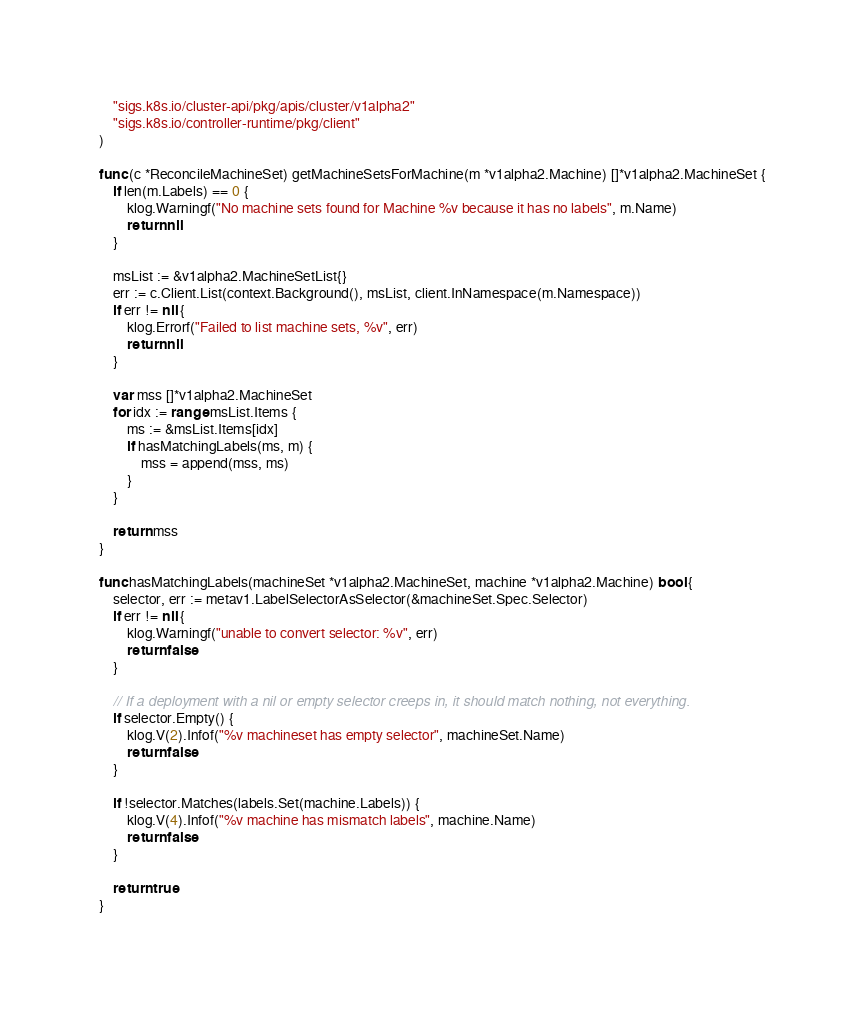Convert code to text. <code><loc_0><loc_0><loc_500><loc_500><_Go_>	"sigs.k8s.io/cluster-api/pkg/apis/cluster/v1alpha2"
	"sigs.k8s.io/controller-runtime/pkg/client"
)

func (c *ReconcileMachineSet) getMachineSetsForMachine(m *v1alpha2.Machine) []*v1alpha2.MachineSet {
	if len(m.Labels) == 0 {
		klog.Warningf("No machine sets found for Machine %v because it has no labels", m.Name)
		return nil
	}

	msList := &v1alpha2.MachineSetList{}
	err := c.Client.List(context.Background(), msList, client.InNamespace(m.Namespace))
	if err != nil {
		klog.Errorf("Failed to list machine sets, %v", err)
		return nil
	}

	var mss []*v1alpha2.MachineSet
	for idx := range msList.Items {
		ms := &msList.Items[idx]
		if hasMatchingLabels(ms, m) {
			mss = append(mss, ms)
		}
	}

	return mss
}

func hasMatchingLabels(machineSet *v1alpha2.MachineSet, machine *v1alpha2.Machine) bool {
	selector, err := metav1.LabelSelectorAsSelector(&machineSet.Spec.Selector)
	if err != nil {
		klog.Warningf("unable to convert selector: %v", err)
		return false
	}

	// If a deployment with a nil or empty selector creeps in, it should match nothing, not everything.
	if selector.Empty() {
		klog.V(2).Infof("%v machineset has empty selector", machineSet.Name)
		return false
	}

	if !selector.Matches(labels.Set(machine.Labels)) {
		klog.V(4).Infof("%v machine has mismatch labels", machine.Name)
		return false
	}

	return true
}
</code> 